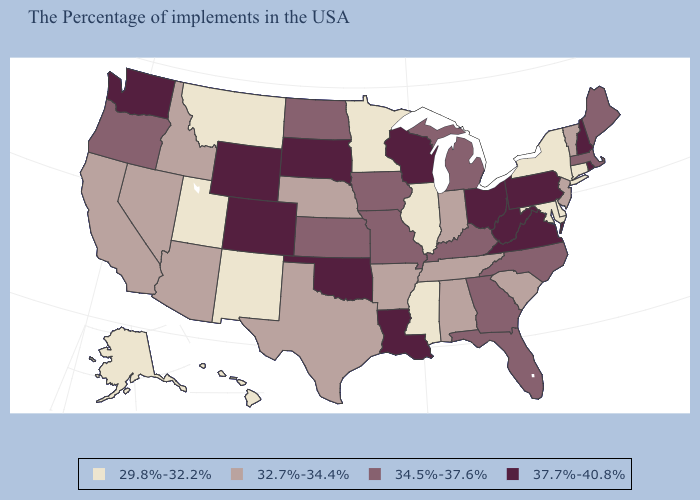Name the states that have a value in the range 32.7%-34.4%?
Concise answer only. Vermont, New Jersey, South Carolina, Indiana, Alabama, Tennessee, Arkansas, Nebraska, Texas, Arizona, Idaho, Nevada, California. What is the lowest value in states that border Michigan?
Quick response, please. 32.7%-34.4%. What is the value of Virginia?
Short answer required. 37.7%-40.8%. Does Louisiana have a higher value than Washington?
Give a very brief answer. No. What is the value of Alaska?
Concise answer only. 29.8%-32.2%. What is the lowest value in the Northeast?
Write a very short answer. 29.8%-32.2%. Does the first symbol in the legend represent the smallest category?
Write a very short answer. Yes. What is the lowest value in states that border Georgia?
Give a very brief answer. 32.7%-34.4%. Which states have the lowest value in the MidWest?
Short answer required. Illinois, Minnesota. How many symbols are there in the legend?
Quick response, please. 4. Is the legend a continuous bar?
Be succinct. No. Is the legend a continuous bar?
Short answer required. No. Name the states that have a value in the range 32.7%-34.4%?
Quick response, please. Vermont, New Jersey, South Carolina, Indiana, Alabama, Tennessee, Arkansas, Nebraska, Texas, Arizona, Idaho, Nevada, California. Name the states that have a value in the range 32.7%-34.4%?
Answer briefly. Vermont, New Jersey, South Carolina, Indiana, Alabama, Tennessee, Arkansas, Nebraska, Texas, Arizona, Idaho, Nevada, California. Which states have the highest value in the USA?
Write a very short answer. Rhode Island, New Hampshire, Pennsylvania, Virginia, West Virginia, Ohio, Wisconsin, Louisiana, Oklahoma, South Dakota, Wyoming, Colorado, Washington. 